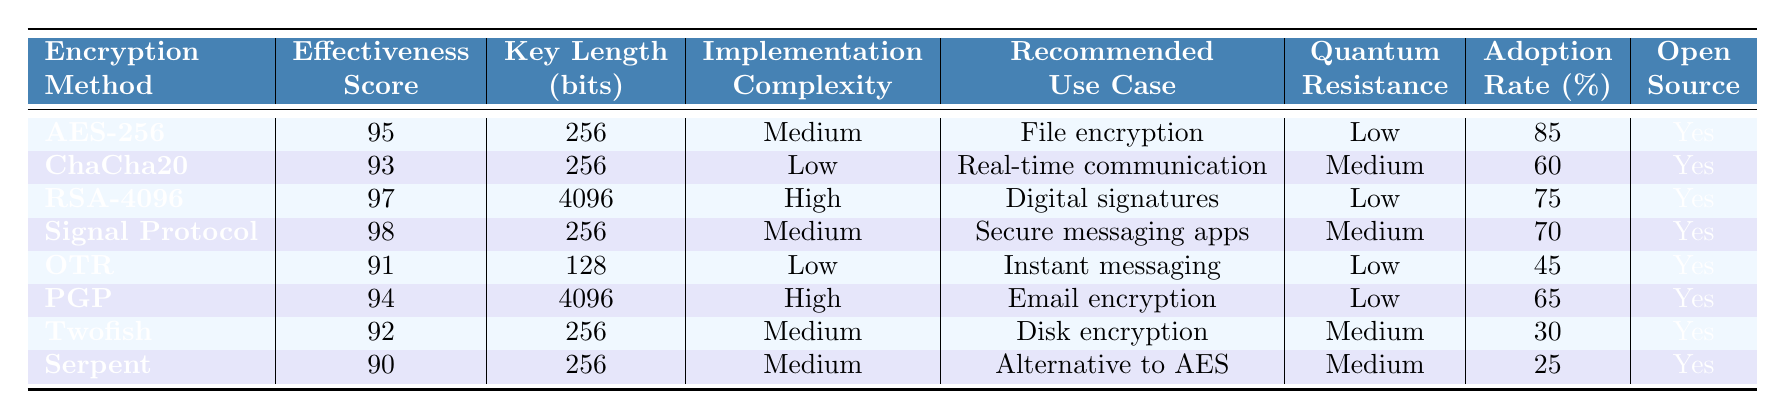What is the effectiveness score of AES-256? The effectiveness score for AES-256 is specifically listed in the table under the 'Effectiveness' column corresponding to AES-256. It shows a score of 95.
Answer: 95 Which encryption method has the highest adoption rate? By looking at the 'Adoption Rate' column, the highest value is 85%, which corresponds to AES-256.
Answer: AES-256 What is the key length of RSA-4096? The table provides the key length for RSA-4096 in the 'Key Length' column, which is 4096 bits.
Answer: 4096 bits Is ChaCha20 an open-source encryption method? The entry for ChaCha20 in the 'Open Source' column shows 'Yes', indicating that it is indeed open-source.
Answer: Yes What is the average effectiveness score of the encryption methods listed? The effectiveness scores are 95, 93, 97, 98, 91, 94, 92, and 90. To find the average, sum these scores (95 + 93 + 97 + 98 + 91 + 94 + 92 + 90 = 90) and divide by the number of methods (8). The average effectiveness score is therefore 94.
Answer: 94 Which encryption method is recommended for secure messaging apps? The 'Recommended Use Case' column indicates that 'Signal Protocol' is listed for secure messaging apps.
Answer: Signal Protocol How many encryption methods have a low resistance to quantum attacks? The 'Resistance to Quantum' column shows 'Low' for AES-256, RSA-4096, OTR, PGP, which totals to four methods.
Answer: 4 Which encryption method has the lowest key length? The method with the lowest key length is OTR, with a key length of 128 bits, according to the 'Key Length' column in the table.
Answer: OTR What is the difference between the effectiveness scores of Signal Protocol and Twofish? Signal Protocol has an effectiveness score of 98, and Twofish has a score of 92. The difference is 98 - 92 = 6.
Answer: 6 Which method has both high implementation complexity and a key length longer than 256 bits? The only method fitting this criteria is RSA-4096, which has 'High' in 'Implementation' and a key length of 4096 bits.
Answer: RSA-4096 